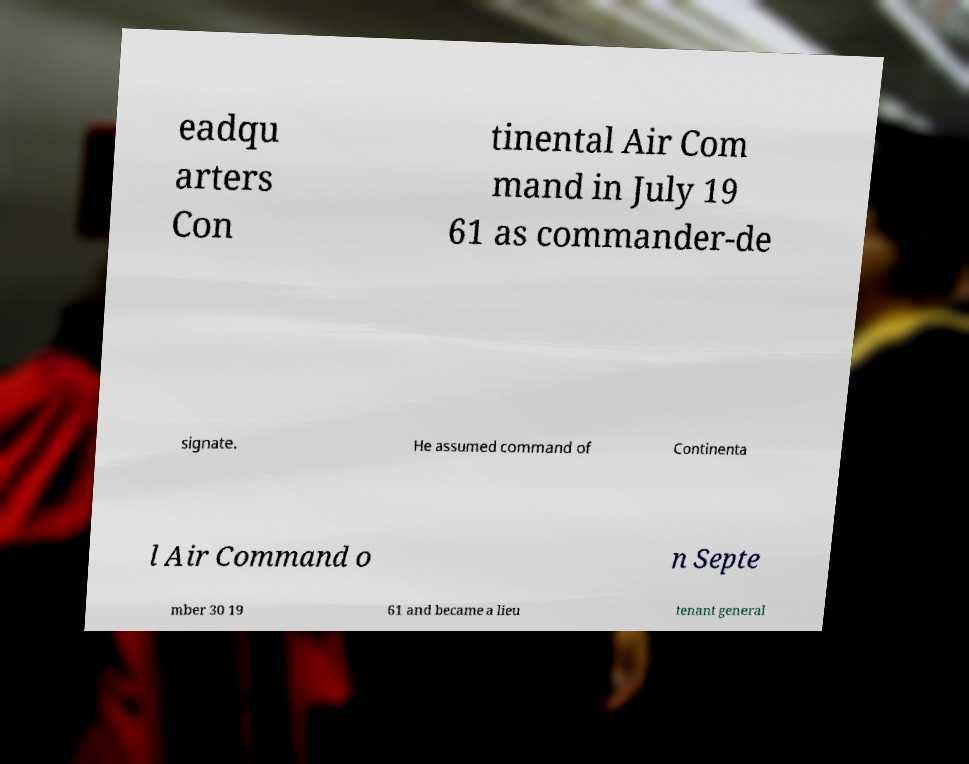For documentation purposes, I need the text within this image transcribed. Could you provide that? eadqu arters Con tinental Air Com mand in July 19 61 as commander-de signate. He assumed command of Continenta l Air Command o n Septe mber 30 19 61 and became a lieu tenant general 